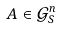<formula> <loc_0><loc_0><loc_500><loc_500>A \in { \mathcal { G } } ^ { n } _ { S }</formula> 